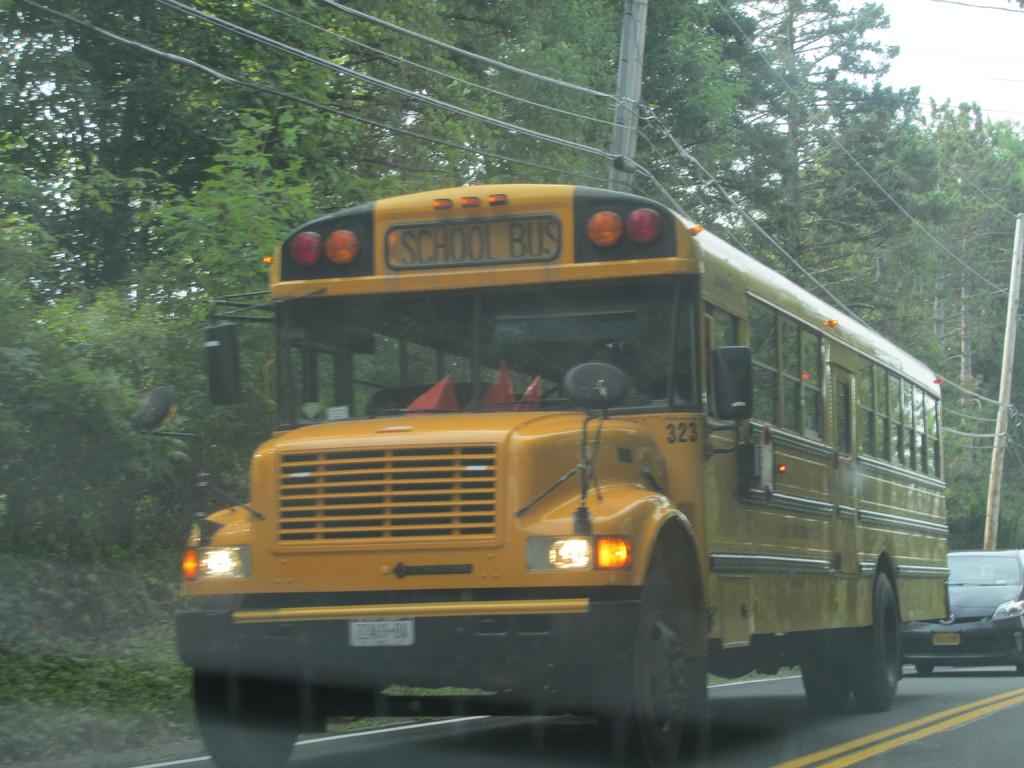<image>
Offer a succinct explanation of the picture presented. A yellow bus with School Bus written on the front. 